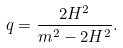<formula> <loc_0><loc_0><loc_500><loc_500>q = \frac { 2 H ^ { 2 } } { m ^ { 2 } - 2 H ^ { 2 } } .</formula> 